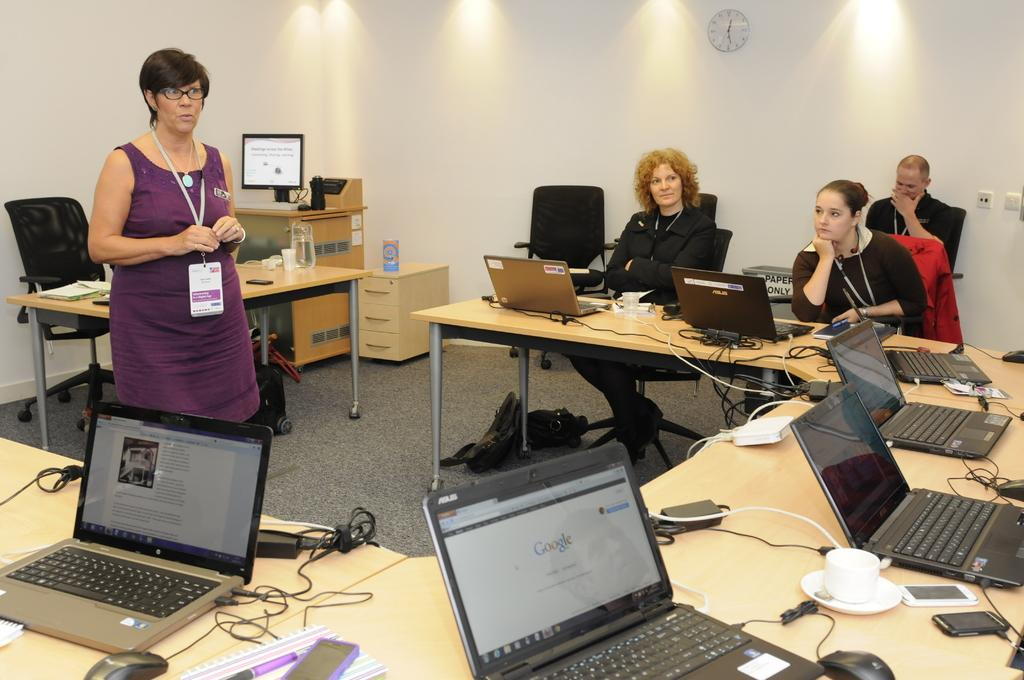<image>
Render a clear and concise summary of the photo. People in a room with laptops one laptop is on a Google search webpage. 